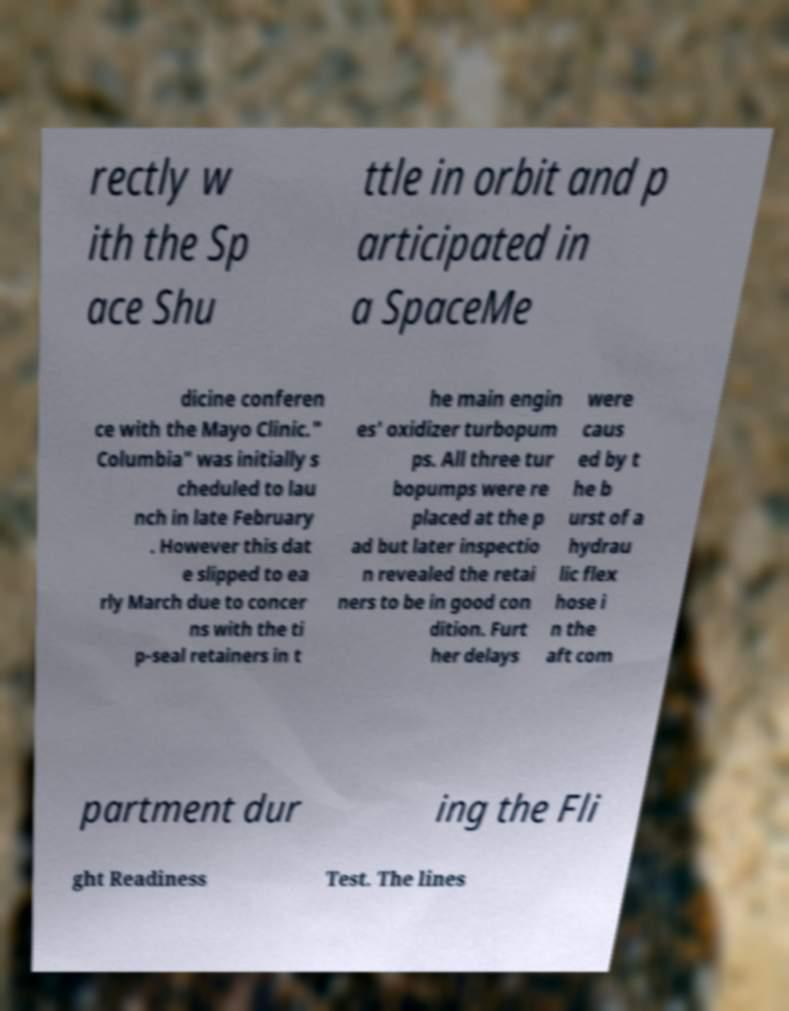What messages or text are displayed in this image? I need them in a readable, typed format. rectly w ith the Sp ace Shu ttle in orbit and p articipated in a SpaceMe dicine conferen ce with the Mayo Clinic." Columbia" was initially s cheduled to lau nch in late February . However this dat e slipped to ea rly March due to concer ns with the ti p-seal retainers in t he main engin es' oxidizer turbopum ps. All three tur bopumps were re placed at the p ad but later inspectio n revealed the retai ners to be in good con dition. Furt her delays were caus ed by t he b urst of a hydrau lic flex hose i n the aft com partment dur ing the Fli ght Readiness Test. The lines 